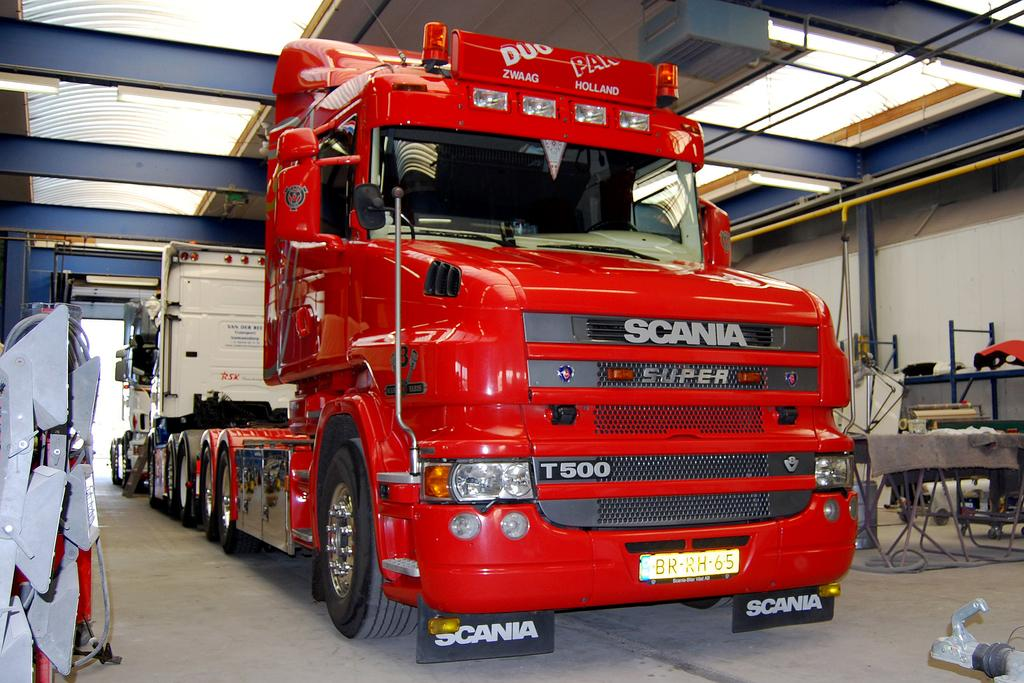What is the main subject in the center of the image? There is a truck in the center of the image. What color is the truck? The truck is red in color. What else can be seen on the right side of the image? There is a table on the right side of the image. How many ornaments are hanging from the truck in the image? There are no ornaments hanging from the truck in the image. Are the brothers playing with the truck in the image? There is no mention of brothers or any people playing with the truck in the image. 